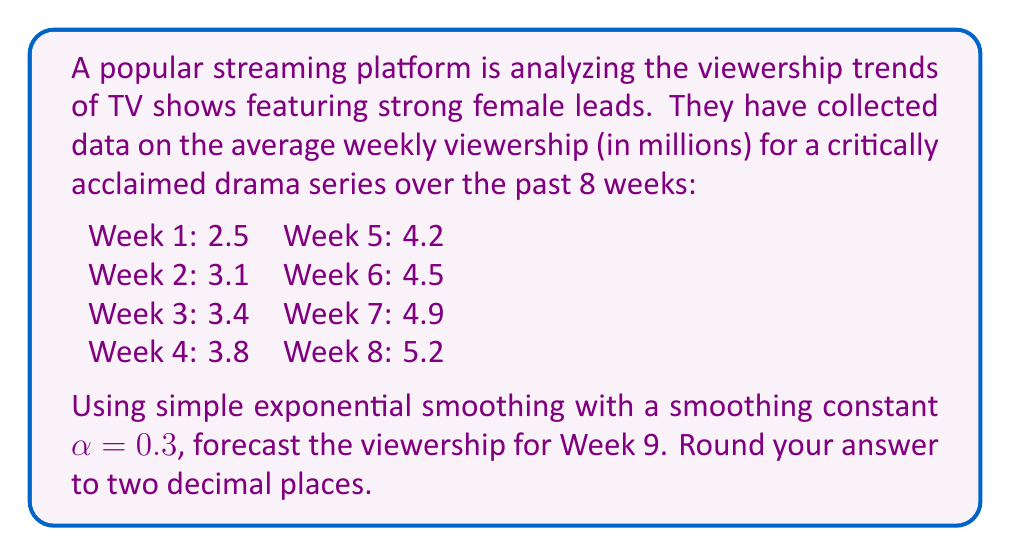Could you help me with this problem? To solve this problem, we'll use the simple exponential smoothing formula:

$$F_{t+1} = \alpha Y_t + (1-\alpha)F_t$$

Where:
$F_{t+1}$ is the forecast for the next period
$\alpha$ is the smoothing constant (0.3 in this case)
$Y_t$ is the actual value at time t
$F_t$ is the forecast for the current period

We'll start by calculating the forecast for each week, beginning with Week 2:

1) For Week 2, we use the Week 1 value as our initial forecast:
   $F_2 = 2.5$

2) For Week 3:
   $F_3 = 0.3(3.1) + (1-0.3)(2.5) = 0.93 + 1.75 = 2.68$

3) For Week 4:
   $F_4 = 0.3(3.4) + (1-0.3)(2.68) = 1.02 + 1.876 = 2.896$

4) For Week 5:
   $F_5 = 0.3(3.8) + (1-0.3)(2.896) = 1.14 + 2.0272 = 3.1672$

5) For Week 6:
   $F_6 = 0.3(4.2) + (1-0.3)(3.1672) = 1.26 + 2.21704 = 3.47704$

6) For Week 7:
   $F_7 = 0.3(4.5) + (1-0.3)(3.47704) = 1.35 + 2.433928 = 3.783928$

7) For Week 8:
   $F_8 = 0.3(4.9) + (1-0.3)(3.783928) = 1.47 + 2.6487496 = 4.1187496$

8) Finally, for Week 9:
   $F_9 = 0.3(5.2) + (1-0.3)(4.1187496) = 1.56 + 2.8831247 = 4.4431247$

Rounding to two decimal places, we get 4.44 million viewers.
Answer: 4.44 million viewers 